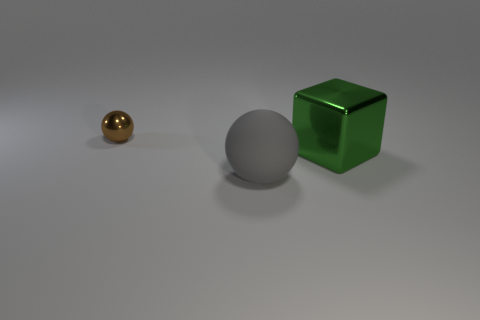There is a thing that is both behind the gray matte ball and on the left side of the block; what size is it?
Ensure brevity in your answer.  Small. What number of brown metallic balls are the same size as the green block?
Keep it short and to the point. 0. How big is the metal ball?
Offer a very short reply. Small. How many objects are in front of the green cube?
Make the answer very short. 1. There is a big green object that is the same material as the small brown thing; what is its shape?
Your response must be concise. Cube. Is the number of large green cubes that are to the left of the tiny thing less than the number of small balls that are behind the matte sphere?
Offer a very short reply. Yes. Is the number of rubber cylinders greater than the number of tiny brown shiny spheres?
Your response must be concise. No. What is the gray ball made of?
Provide a short and direct response. Rubber. What color is the ball in front of the small shiny ball?
Give a very brief answer. Gray. Are there more tiny balls to the left of the big green metallic block than large green blocks left of the big gray ball?
Provide a short and direct response. Yes. 